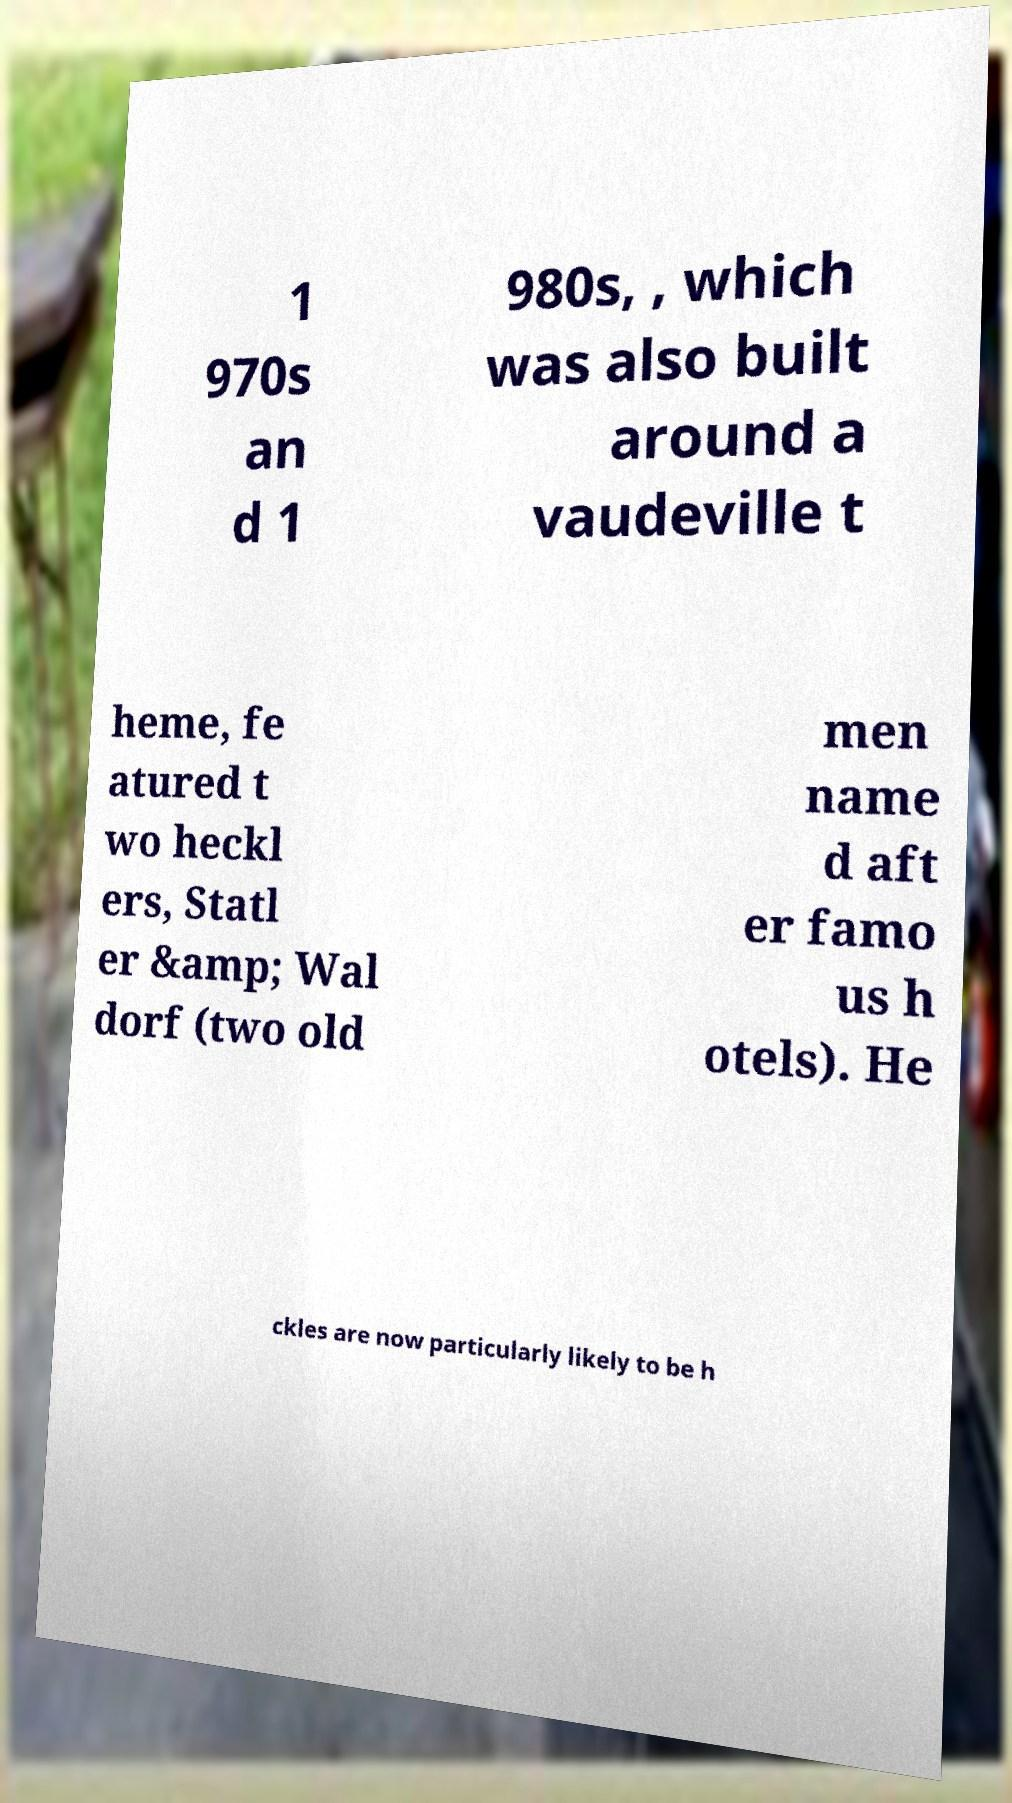Could you assist in decoding the text presented in this image and type it out clearly? 1 970s an d 1 980s, , which was also built around a vaudeville t heme, fe atured t wo heckl ers, Statl er &amp; Wal dorf (two old men name d aft er famo us h otels). He ckles are now particularly likely to be h 